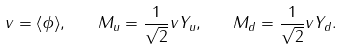<formula> <loc_0><loc_0><loc_500><loc_500>v = \langle \phi \rangle , \quad M _ { u } = \frac { 1 } { \sqrt { 2 } } v Y _ { u } , \quad M _ { d } = \frac { 1 } { \sqrt { 2 } } v Y _ { d } .</formula> 